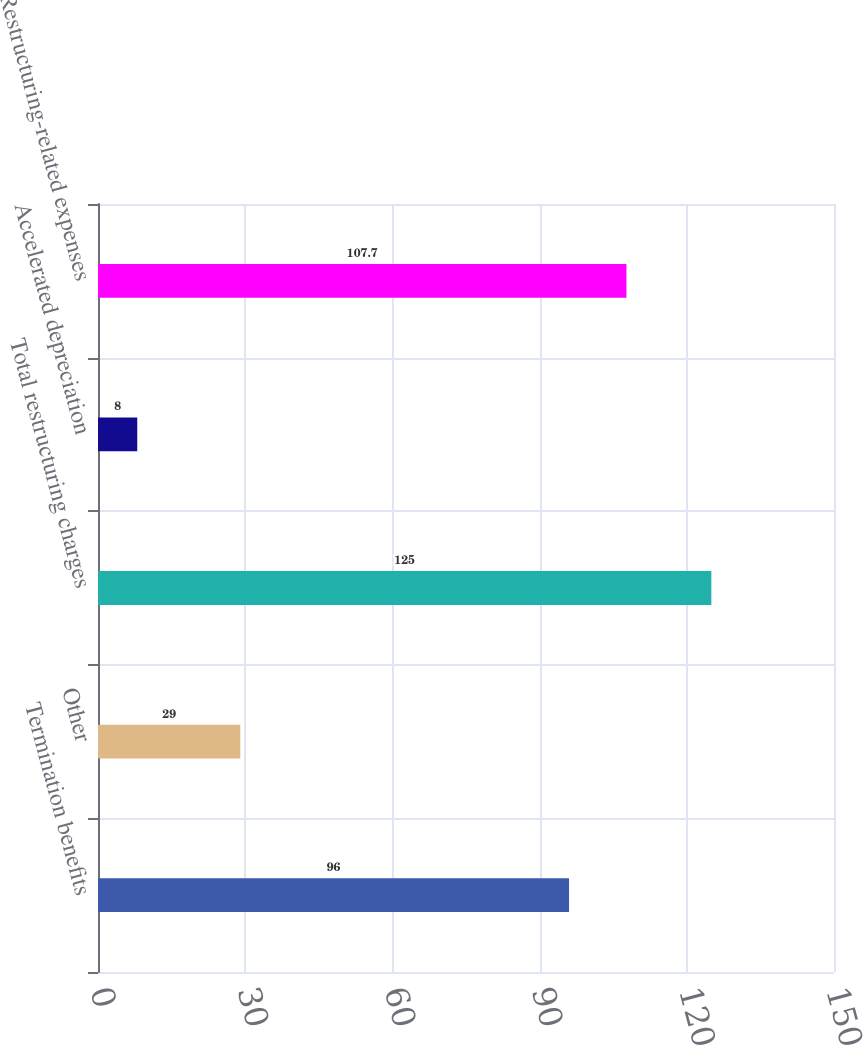Convert chart. <chart><loc_0><loc_0><loc_500><loc_500><bar_chart><fcel>Termination benefits<fcel>Other<fcel>Total restructuring charges<fcel>Accelerated depreciation<fcel>Restructuring-related expenses<nl><fcel>96<fcel>29<fcel>125<fcel>8<fcel>107.7<nl></chart> 